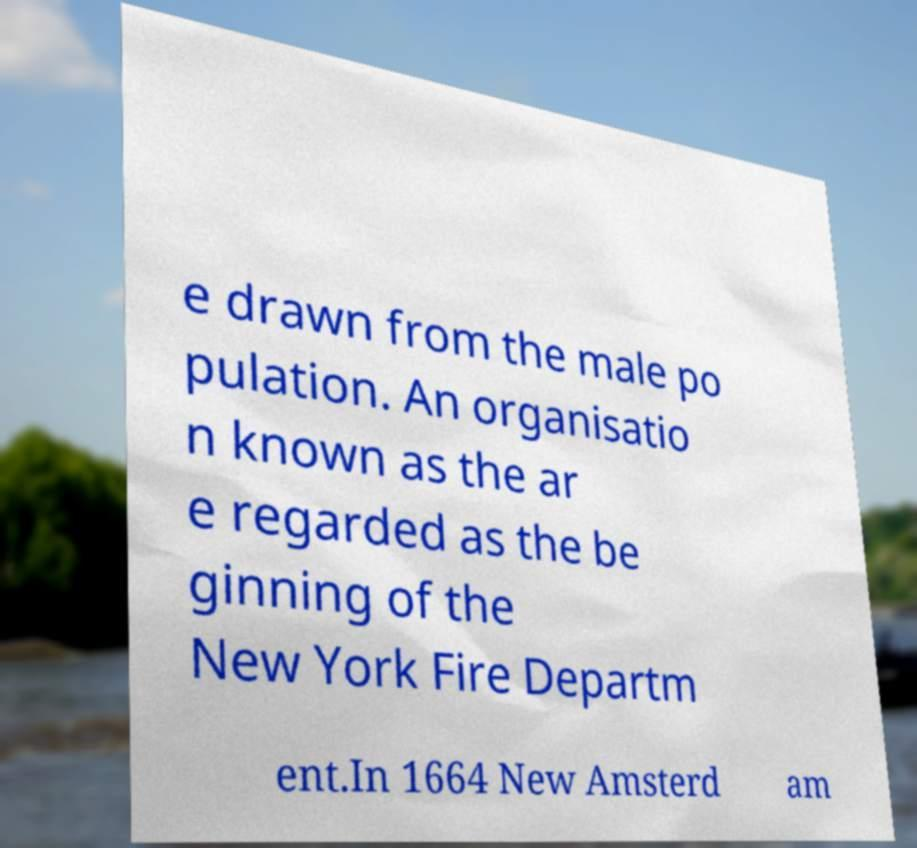Please identify and transcribe the text found in this image. e drawn from the male po pulation. An organisatio n known as the ar e regarded as the be ginning of the New York Fire Departm ent.In 1664 New Amsterd am 